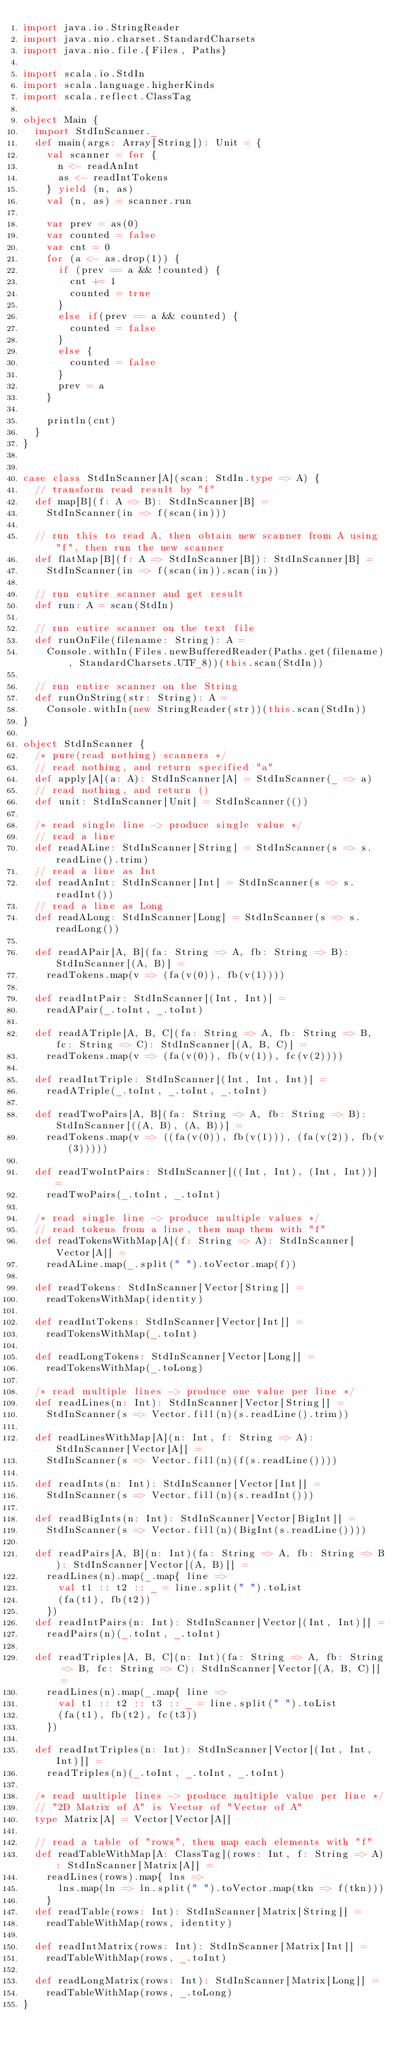<code> <loc_0><loc_0><loc_500><loc_500><_Scala_>import java.io.StringReader
import java.nio.charset.StandardCharsets
import java.nio.file.{Files, Paths}

import scala.io.StdIn
import scala.language.higherKinds
import scala.reflect.ClassTag

object Main {
  import StdInScanner._
  def main(args: Array[String]): Unit = {
    val scanner = for {
      n <- readAnInt
      as <- readIntTokens
    } yield (n, as)
    val (n, as) = scanner.run

    var prev = as(0)
    var counted = false
    var cnt = 0
    for (a <- as.drop(1)) {
      if (prev == a && !counted) {
        cnt += 1
        counted = true
      }
      else if(prev == a && counted) {
        counted = false
      }
      else {
        counted = false
      }
      prev = a
    }

    println(cnt)
  }
}


case class StdInScanner[A](scan: StdIn.type => A) {
  // transform read result by "f"
  def map[B](f: A => B): StdInScanner[B] =
    StdInScanner(in => f(scan(in)))

  // run this to read A, then obtain new scanner from A using "f", then run the new scanner
  def flatMap[B](f: A => StdInScanner[B]): StdInScanner[B] =
    StdInScanner(in => f(scan(in)).scan(in))

  // run entire scanner and get result
  def run: A = scan(StdIn)

  // run entire scanner on the text file
  def runOnFile(filename: String): A =
    Console.withIn(Files.newBufferedReader(Paths.get(filename), StandardCharsets.UTF_8))(this.scan(StdIn))

  // run entire scanner on the String
  def runOnString(str: String): A =
    Console.withIn(new StringReader(str))(this.scan(StdIn))
}

object StdInScanner {
  /* pure(read nothing) scanners */
  // read nothing, and return specified "a"
  def apply[A](a: A): StdInScanner[A] = StdInScanner(_ => a)
  // read nothing, and return ()
  def unit: StdInScanner[Unit] = StdInScanner(())

  /* read single line -> produce single value */
  // read a line
  def readALine: StdInScanner[String] = StdInScanner(s => s.readLine().trim)
  // read a line as Int
  def readAnInt: StdInScanner[Int] = StdInScanner(s => s.readInt())
  // read a line as Long
  def readALong: StdInScanner[Long] = StdInScanner(s => s.readLong())

  def readAPair[A, B](fa: String => A, fb: String => B): StdInScanner[(A, B)] =
    readTokens.map(v => (fa(v(0)), fb(v(1))))

  def readIntPair: StdInScanner[(Int, Int)] =
    readAPair(_.toInt, _.toInt)

  def readATriple[A, B, C](fa: String => A, fb: String => B, fc: String => C): StdInScanner[(A, B, C)] =
    readTokens.map(v => (fa(v(0)), fb(v(1)), fc(v(2))))

  def readIntTriple: StdInScanner[(Int, Int, Int)] =
    readATriple(_.toInt, _.toInt, _.toInt)

  def readTwoPairs[A, B](fa: String => A, fb: String => B): StdInScanner[((A, B), (A, B))] =
    readTokens.map(v => ((fa(v(0)), fb(v(1))), (fa(v(2)), fb(v(3)))))

  def readTwoIntPairs: StdInScanner[((Int, Int), (Int, Int))] =
    readTwoPairs(_.toInt, _.toInt)

  /* read single line -> produce multiple values */
  // read tokens from a line, then map them with "f"
  def readTokensWithMap[A](f: String => A): StdInScanner[Vector[A]] =
    readALine.map(_.split(" ").toVector.map(f))

  def readTokens: StdInScanner[Vector[String]] =
    readTokensWithMap(identity)

  def readIntTokens: StdInScanner[Vector[Int]] =
    readTokensWithMap(_.toInt)

  def readLongTokens: StdInScanner[Vector[Long]] =
    readTokensWithMap(_.toLong)

  /* read multiple lines -> produce one value per line */
  def readLines(n: Int): StdInScanner[Vector[String]] =
    StdInScanner(s => Vector.fill(n)(s.readLine().trim))

  def readLinesWithMap[A](n: Int, f: String => A): StdInScanner[Vector[A]] =
    StdInScanner(s => Vector.fill(n)(f(s.readLine())))

  def readInts(n: Int): StdInScanner[Vector[Int]] =
    StdInScanner(s => Vector.fill(n)(s.readInt()))

  def readBigInts(n: Int): StdInScanner[Vector[BigInt]] =
    StdInScanner(s => Vector.fill(n)(BigInt(s.readLine())))

  def readPairs[A, B](n: Int)(fa: String => A, fb: String => B): StdInScanner[Vector[(A, B)]] =
    readLines(n).map(_.map{ line =>
      val t1 :: t2 :: _ = line.split(" ").toList
      (fa(t1), fb(t2))
    })
  def readIntPairs(n: Int): StdInScanner[Vector[(Int, Int)]] =
    readPairs(n)(_.toInt, _.toInt)

  def readTriples[A, B, C](n: Int)(fa: String => A, fb: String => B, fc: String => C): StdInScanner[Vector[(A, B, C)]] =
    readLines(n).map(_.map{ line =>
      val t1 :: t2 :: t3 :: _ = line.split(" ").toList
      (fa(t1), fb(t2), fc(t3))
    })

  def readIntTriples(n: Int): StdInScanner[Vector[(Int, Int, Int)]] =
    readTriples(n)(_.toInt, _.toInt, _.toInt)

  /* read multiple lines -> produce multiple value per line */
  // "2D Matrix of A" is Vector of "Vector of A"
  type Matrix[A] = Vector[Vector[A]]

  // read a table of "rows", then map each elements with "f"
  def readTableWithMap[A: ClassTag](rows: Int, f: String => A): StdInScanner[Matrix[A]] =
    readLines(rows).map{ lns =>
      lns.map(ln => ln.split(" ").toVector.map(tkn => f(tkn)))
    }
  def readTable(rows: Int): StdInScanner[Matrix[String]] =
    readTableWithMap(rows, identity)

  def readIntMatrix(rows: Int): StdInScanner[Matrix[Int]] =
    readTableWithMap(rows, _.toInt)

  def readLongMatrix(rows: Int): StdInScanner[Matrix[Long]] =
    readTableWithMap(rows, _.toLong)
}
</code> 